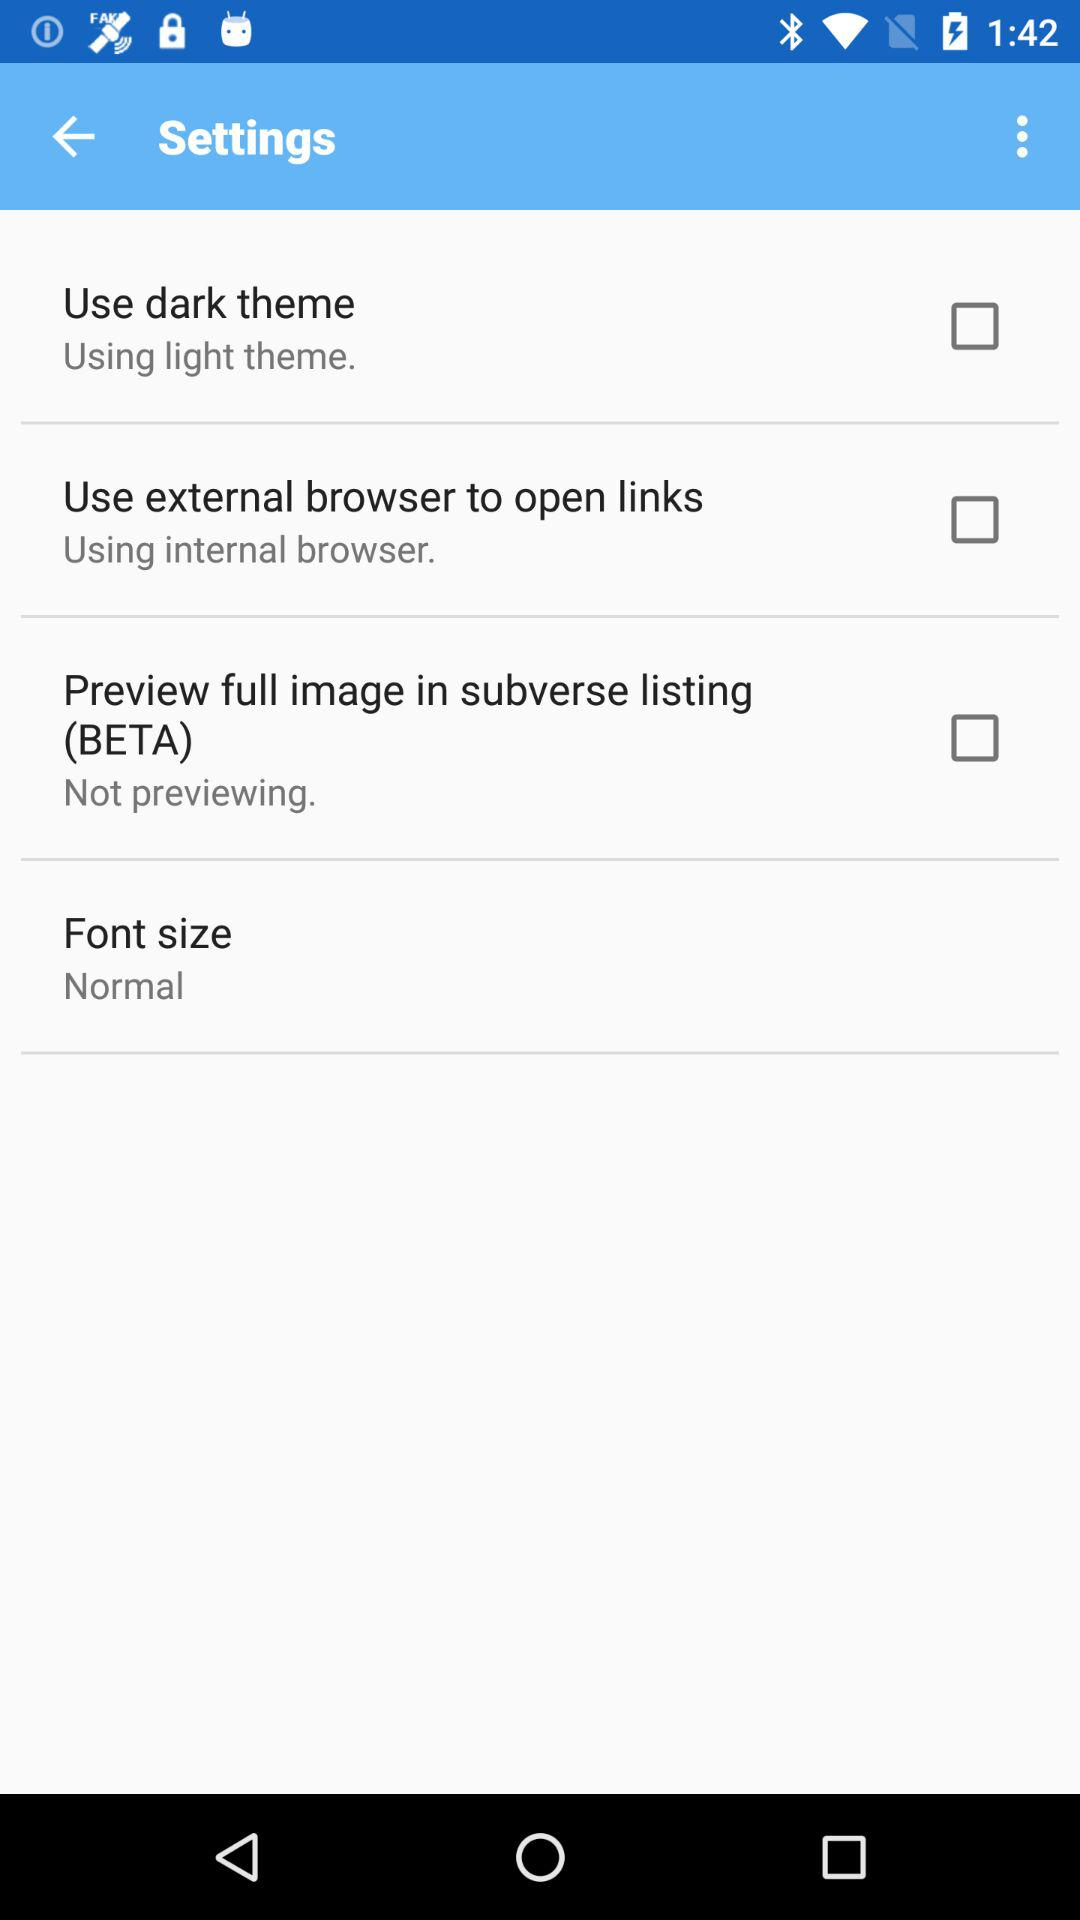What is "Font size"? "Font size" is "Normal". 